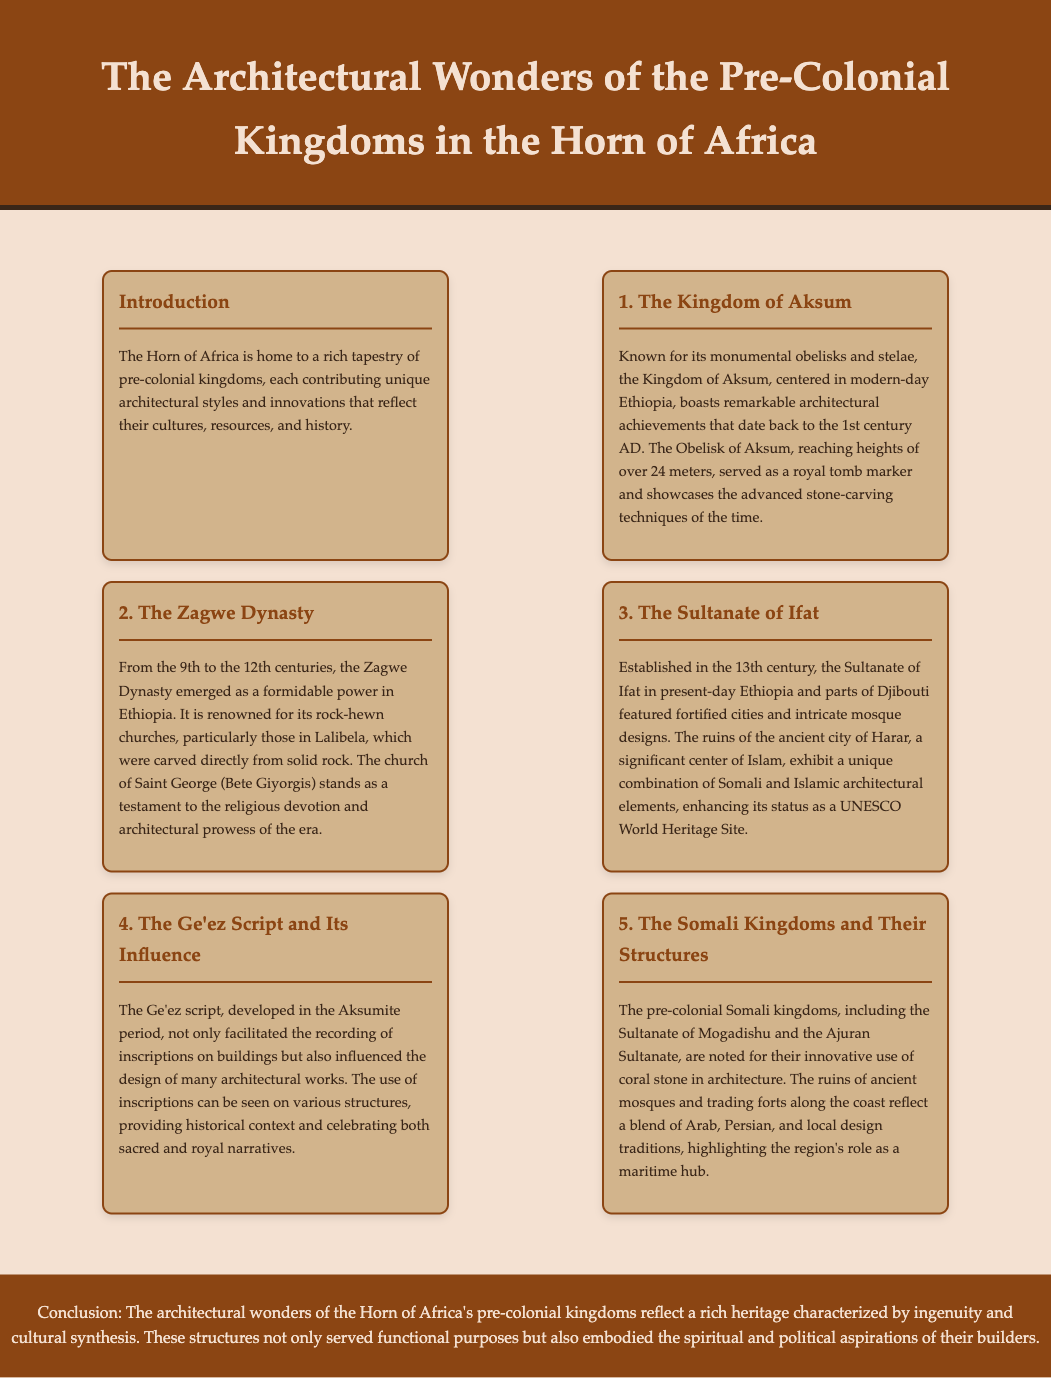What is the title of the document? The title can be found in the header of the document, stating the subject matter clearly.
Answer: The Architectural Wonders of the Pre-Colonial Kingdoms in the Horn of Africa Which kingdom is known for its monumental obelisks? This information is highlighted in the menu item dedicated to the Kingdom of Aksum, emphasizing its architectural achievements.
Answer: Kingdom of Aksum What architectural feature is the Zagwe Dynasty renowned for? The discussion about the Zagwe Dynasty specifically mentions a significant architectural feature in its description.
Answer: Rock-hewn churches What significant center of Islam is mentioned in relation to the Sultanate of Ifat? The mention of historical sites related to Islam can be found in the context of the Sultanate of Ifat's achievements.
Answer: Harar What script's development is tied to the Aksumite period? The Ge'ez script is noted for its historical significance in the context of the Aksumite period as discussed in the document.
Answer: Ge'ez script During which centuries did the Zagwe Dynasty exist? The time frame for the Zagwe Dynasty is clearly stated in its respective section.
Answer: 9th to 12th centuries What is notable about the architectural materials used by the pre-colonial Somali kingdoms? The document specifies the type of materials used in the architecture of the Somali kingdoms, highlighting their uniqueness.
Answer: Coral stone What does the conclusion emphasize about the architectural wonders? The concluding remarks summarize the overall significance of the structures discussed in the document.
Answer: Rich heritage 